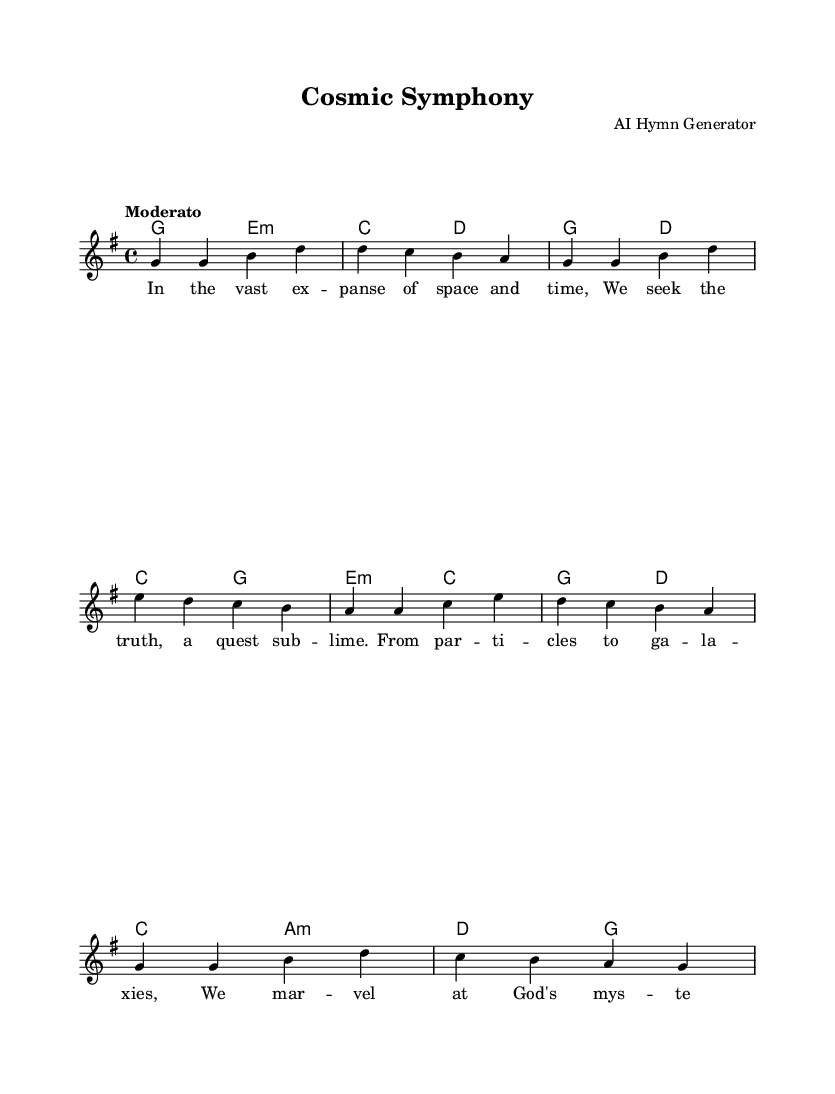What is the key signature of this music? The key signature is indicated at the beginning of the staff. The presence of one sharp (F#) indicates that the piece is in G major.
Answer: G major What is the time signature of this music? The time signature is found after the key signature. The notation “4/4” indicates that there are four beats in a measure, and the quarter note gets one beat.
Answer: 4/4 What is the tempo marking for this piece? The tempo marking is provided in the score as "Moderato," which suggests a moderate pace.
Answer: Moderato How many measures does the melody section contain? The melody consists of a series of notes divided into measures; counting them reveals there are eight measures.
Answer: Eight What is the structure of the lyrics in relation to the music? The lyrics follow a verse structure with four lines that fit the melody. This format is typical in hymns, allowing for an easy sing-along experience.
Answer: Verse What chords are used in the first two measures? The chords shown in the score indicate that the first two measures are accompanied by G major and E minor, identified by their symbols at the beginning of the measures.
Answer: G and E minor Which theme is celebrated in the lyrics? The lyrics reflect themes of discovery and wonder in the universe, emphasizing a quest for truth and an exploration of divine mysteries, which is a central theme in gospel hymns.
Answer: Discovery and wonder 